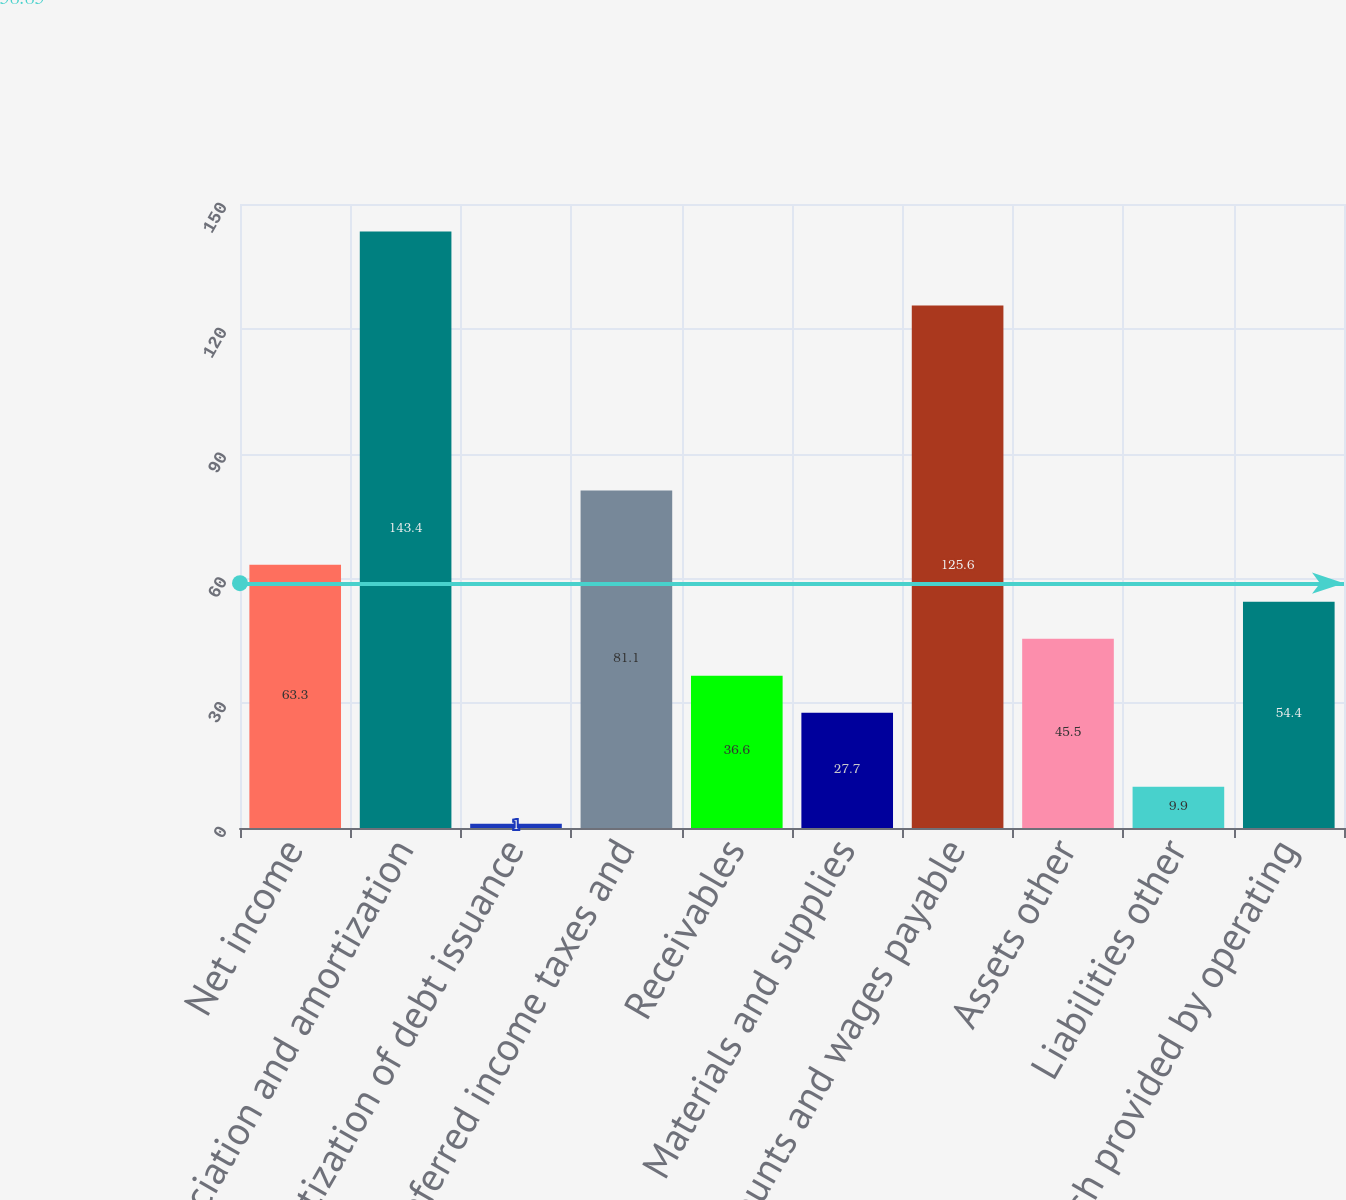<chart> <loc_0><loc_0><loc_500><loc_500><bar_chart><fcel>Net income<fcel>Depreciation and amortization<fcel>Amortization of debt issuance<fcel>Deferred income taxes and<fcel>Receivables<fcel>Materials and supplies<fcel>Accounts and wages payable<fcel>Assets other<fcel>Liabilities other<fcel>Net cash provided by operating<nl><fcel>63.3<fcel>143.4<fcel>1<fcel>81.1<fcel>36.6<fcel>27.7<fcel>125.6<fcel>45.5<fcel>9.9<fcel>54.4<nl></chart> 